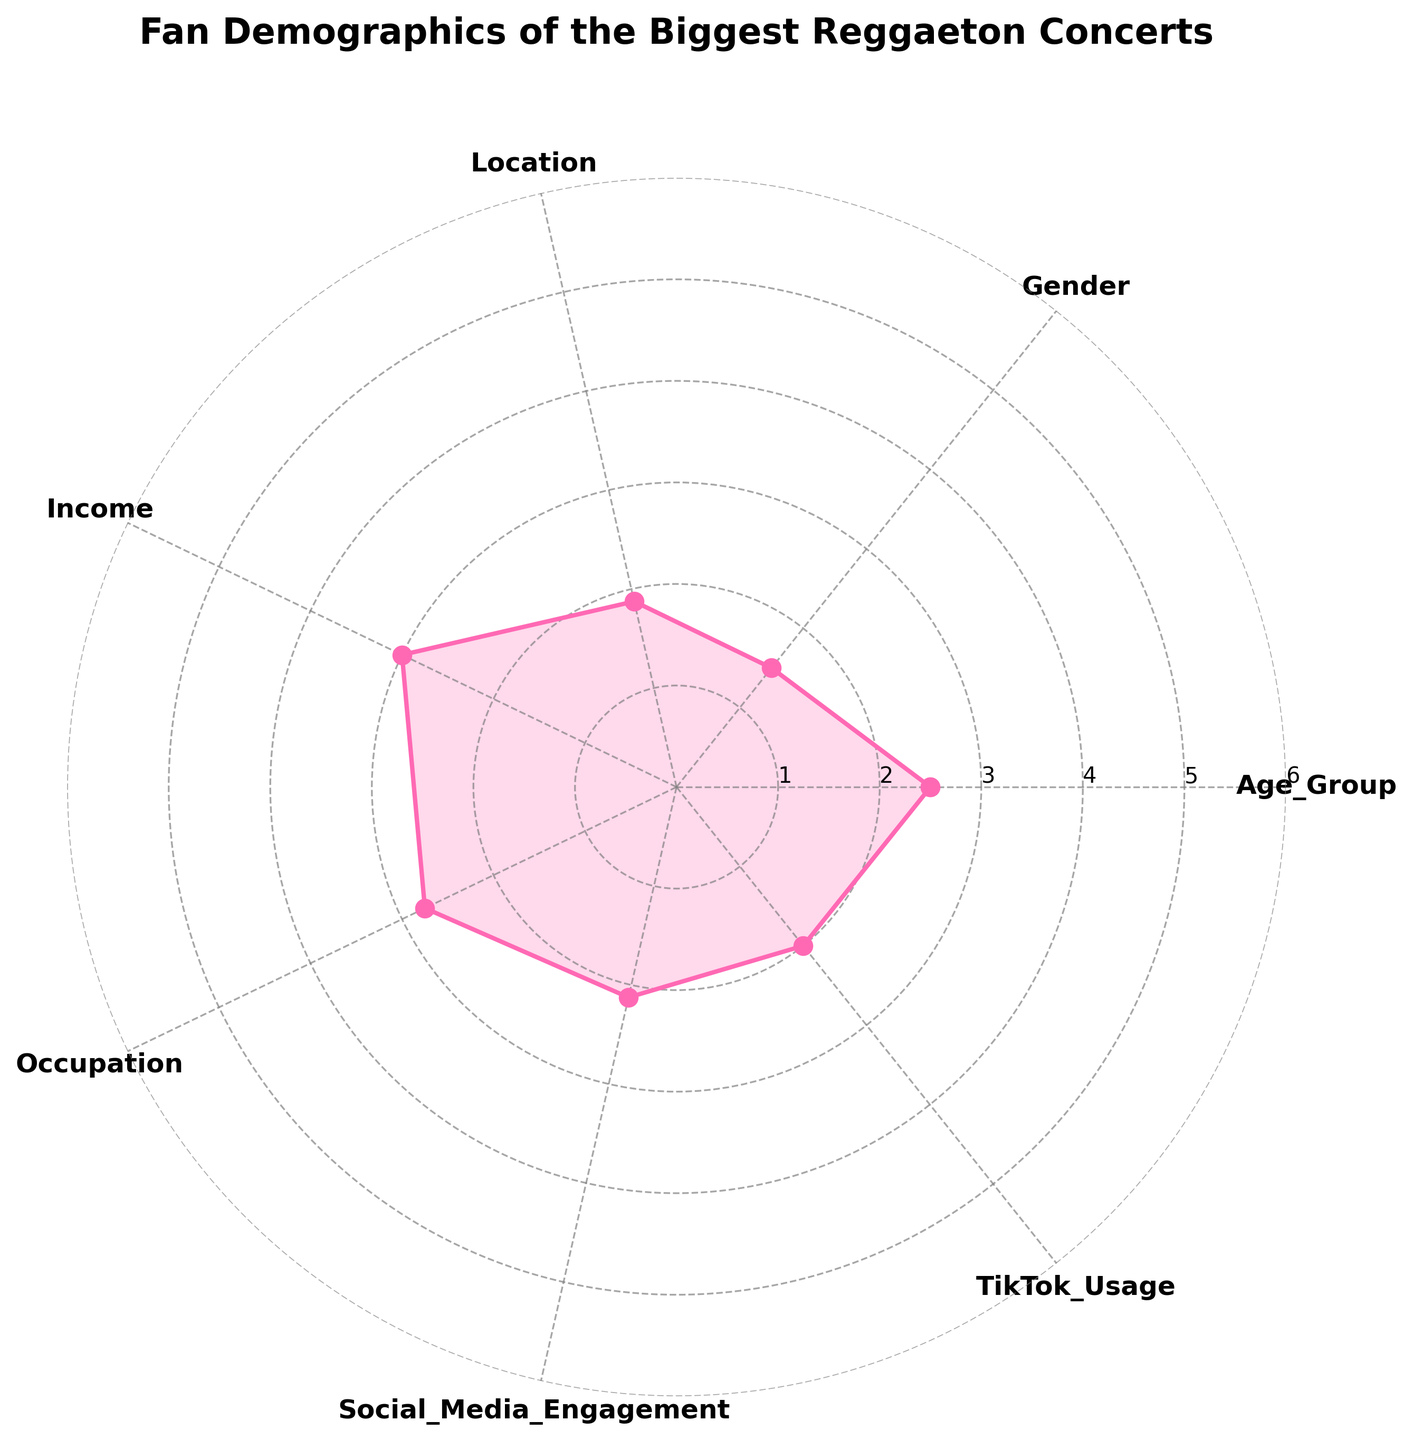What's the title of the radar chart? The title is the text at the top of the radar chart that explains what the chart represents. Here, it's clearly displayed at the top.
Answer: Fan Demographics of the Biggest Reggaeton Concerts Which category has the lowest average value? To find this, look at the radial axis values for each category and identify the one with the lowest value.
Answer: TikTok Usage What is the average value for Income? Identify the radial axis values for Income and then find the average by referring to the plot. This is the first data point after the baseline.
Answer: Approximately 3.5 Compare the values for Gender and Occupation. Which one is higher? Look at the radial axis values for both Gender and Occupation and compare them.
Answer: Gender is higher Which category has the highest engagement on social media? The category for Social Media Engagement should have the highest value on the radial axis for engagement.
Answer: Social_Media_Engagement What is the mean value of Location and Income? This requires averaging the values of Location and Income categories. First, find their values on the radial axis and then compute the average.
Answer: Approximately 3.25 How does the value for Age_Group compare with TikTok Usage? Look at the radial values for Age_Group and TikTok Usage and compare their heights on the plot.
Answer: Age_Group is higher On which category does the plot have an angle of approximately 2π/3? The radar chart angles are uniformly distributed, so an angle of 2π/3 corresponds to the second category in the plot after Age_Group.
Answer: Gender What's the difference between the highest and lowest categories on the plot? Identify the highest and lowest values on the radar chart and then subtract the lower value from the higher one.
Answer: Approximately 3 What are the radial limits set on the radar chart? Review the values on the radial axis that indicate the range the data spans.
Answer: 0 to 6 